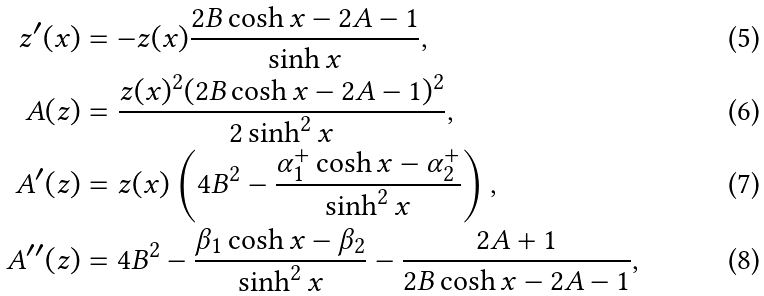Convert formula to latex. <formula><loc_0><loc_0><loc_500><loc_500>z ^ { \prime } ( x ) & = - z ( x ) \frac { 2 B \cosh x - 2 A - 1 } { \sinh x } , \\ A ( z ) & = \frac { z ( x ) ^ { 2 } ( 2 B \cosh x - 2 A - 1 ) ^ { 2 } } { 2 \sinh ^ { 2 } x } , \\ A ^ { \prime } ( z ) & = z ( x ) \left ( 4 B ^ { 2 } - \frac { \alpha _ { 1 } ^ { + } \cosh x - \alpha _ { 2 } ^ { + } } { \sinh ^ { 2 } x } \right ) , \\ A ^ { \prime \prime } ( z ) & = 4 B ^ { 2 } - \frac { \beta _ { 1 } \cosh x - \beta _ { 2 } } { \sinh ^ { 2 } x } - \frac { 2 A + 1 } { 2 B \cosh x - 2 A - 1 } ,</formula> 